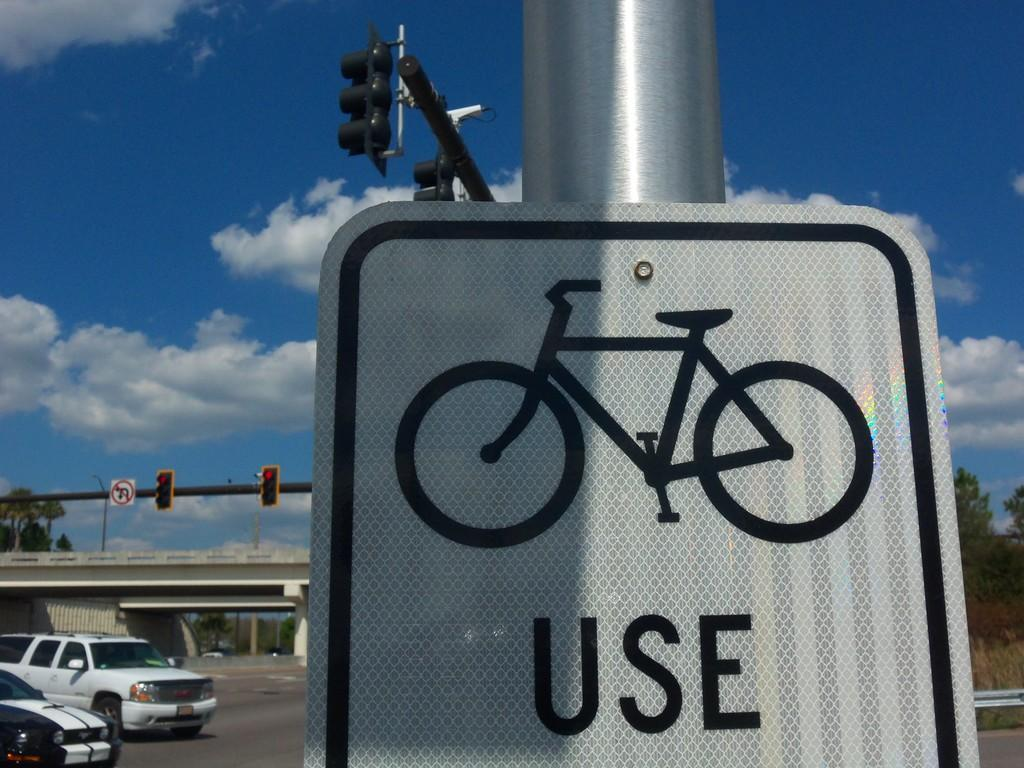<image>
Summarize the visual content of the image. A sign with a bike and the word use on it hangs on a pole by a roadway. 